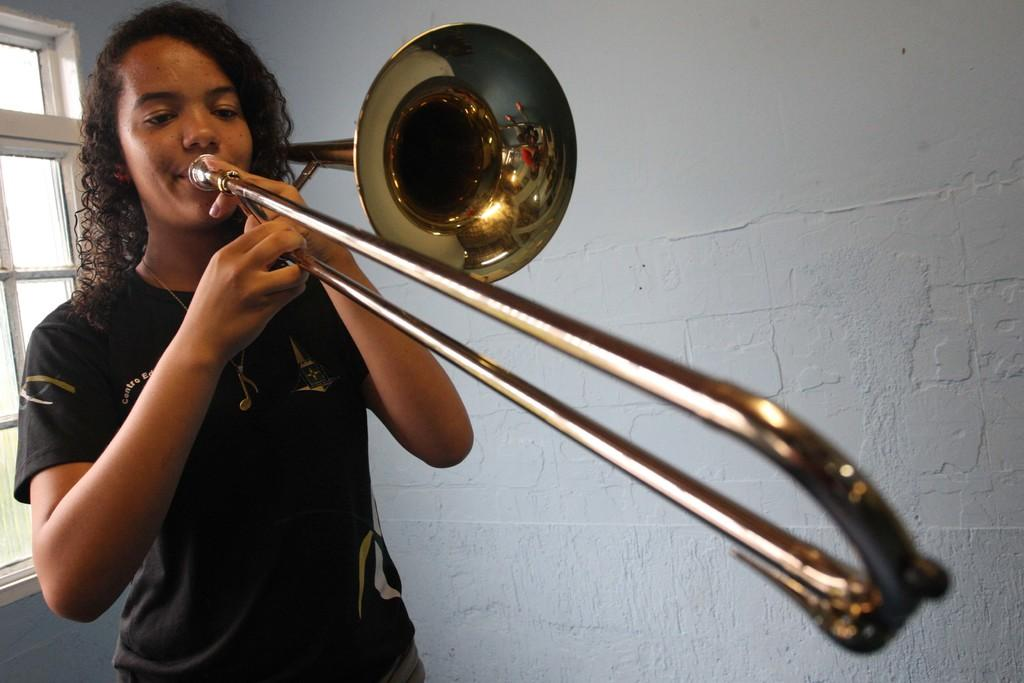What is the main subject of the image? There is a person in the image. What is the person doing in the image? The person is playing a musical instrument. What is located beside the person? There is a wall beside the person. What can be seen in the background of the image? There is a window in the background of the image. What is the person's wealth in the image? There is no information about the person's wealth in the image. --- Facts: 1. There is a person in the image. 2. The person is holding a book. 3. The book is open. 4. The person is sitting on a chair. 5. There is a table in front of the person. Absurd Topics: elephant, bicycle Conversation: What is the main subject of the image? There is a person in the image. What is the person doing in the image? The person is holding a book. What can be observed about the book in the image? The book is open. What is the person's seating arrangement in the image? The person is sitting on a chair. What is located in front of the person in the image? There is a table in front of the person. Reasoning: Let's think step by step in order to produce the conversation. We start by identifying the main subject of the image, which is the person. Next, we describe what the person is doing, which is holding a book. Then, we observe the position of the book, noting that it is open. After that, we mention the person's seating arrangement, which is sitting on a chair. Finally, we describe what is located in front of the person, which is a table. Each question is designed to elicit a specific detail about the image that is known from the provided facts. Absurd Question/Answer: How many elephants can be seen riding a bicycle in the image? There are no elephants or bicycles present in the image. 